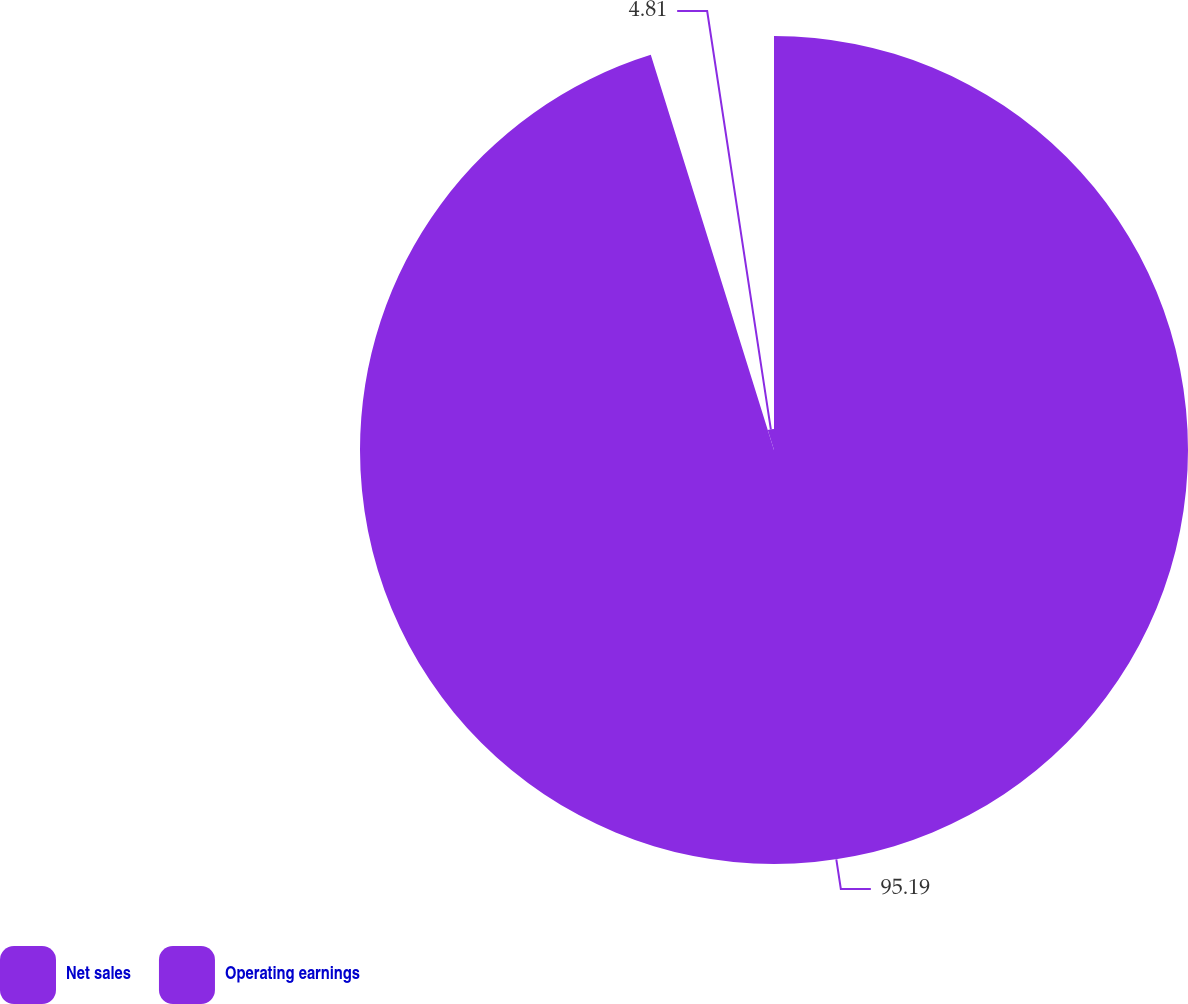<chart> <loc_0><loc_0><loc_500><loc_500><pie_chart><fcel>Net sales<fcel>Operating earnings<nl><fcel>95.19%<fcel>4.81%<nl></chart> 